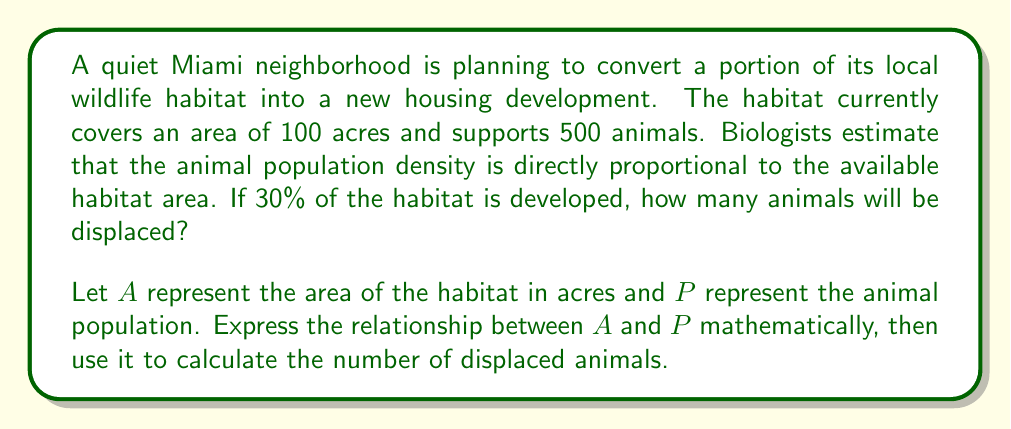Can you solve this math problem? 1. Let's establish the relationship between area and population:
   $P = kA$, where $k$ is the constant of proportionality

2. We can find $k$ using the initial conditions:
   $500 = k(100)$
   $k = 5$ animals per acre

3. The new area after development:
   $A_{new} = 100 - (30\% \times 100) = 100 - 30 = 70$ acres

4. Calculate the new population:
   $P_{new} = kA_{new} = 5 \times 70 = 350$ animals

5. Find the number of displaced animals:
   Displaced animals = Initial population - New population
   $= 500 - 350 = 150$ animals

Therefore, 150 animals will be displaced by the development.
Answer: 150 animals 